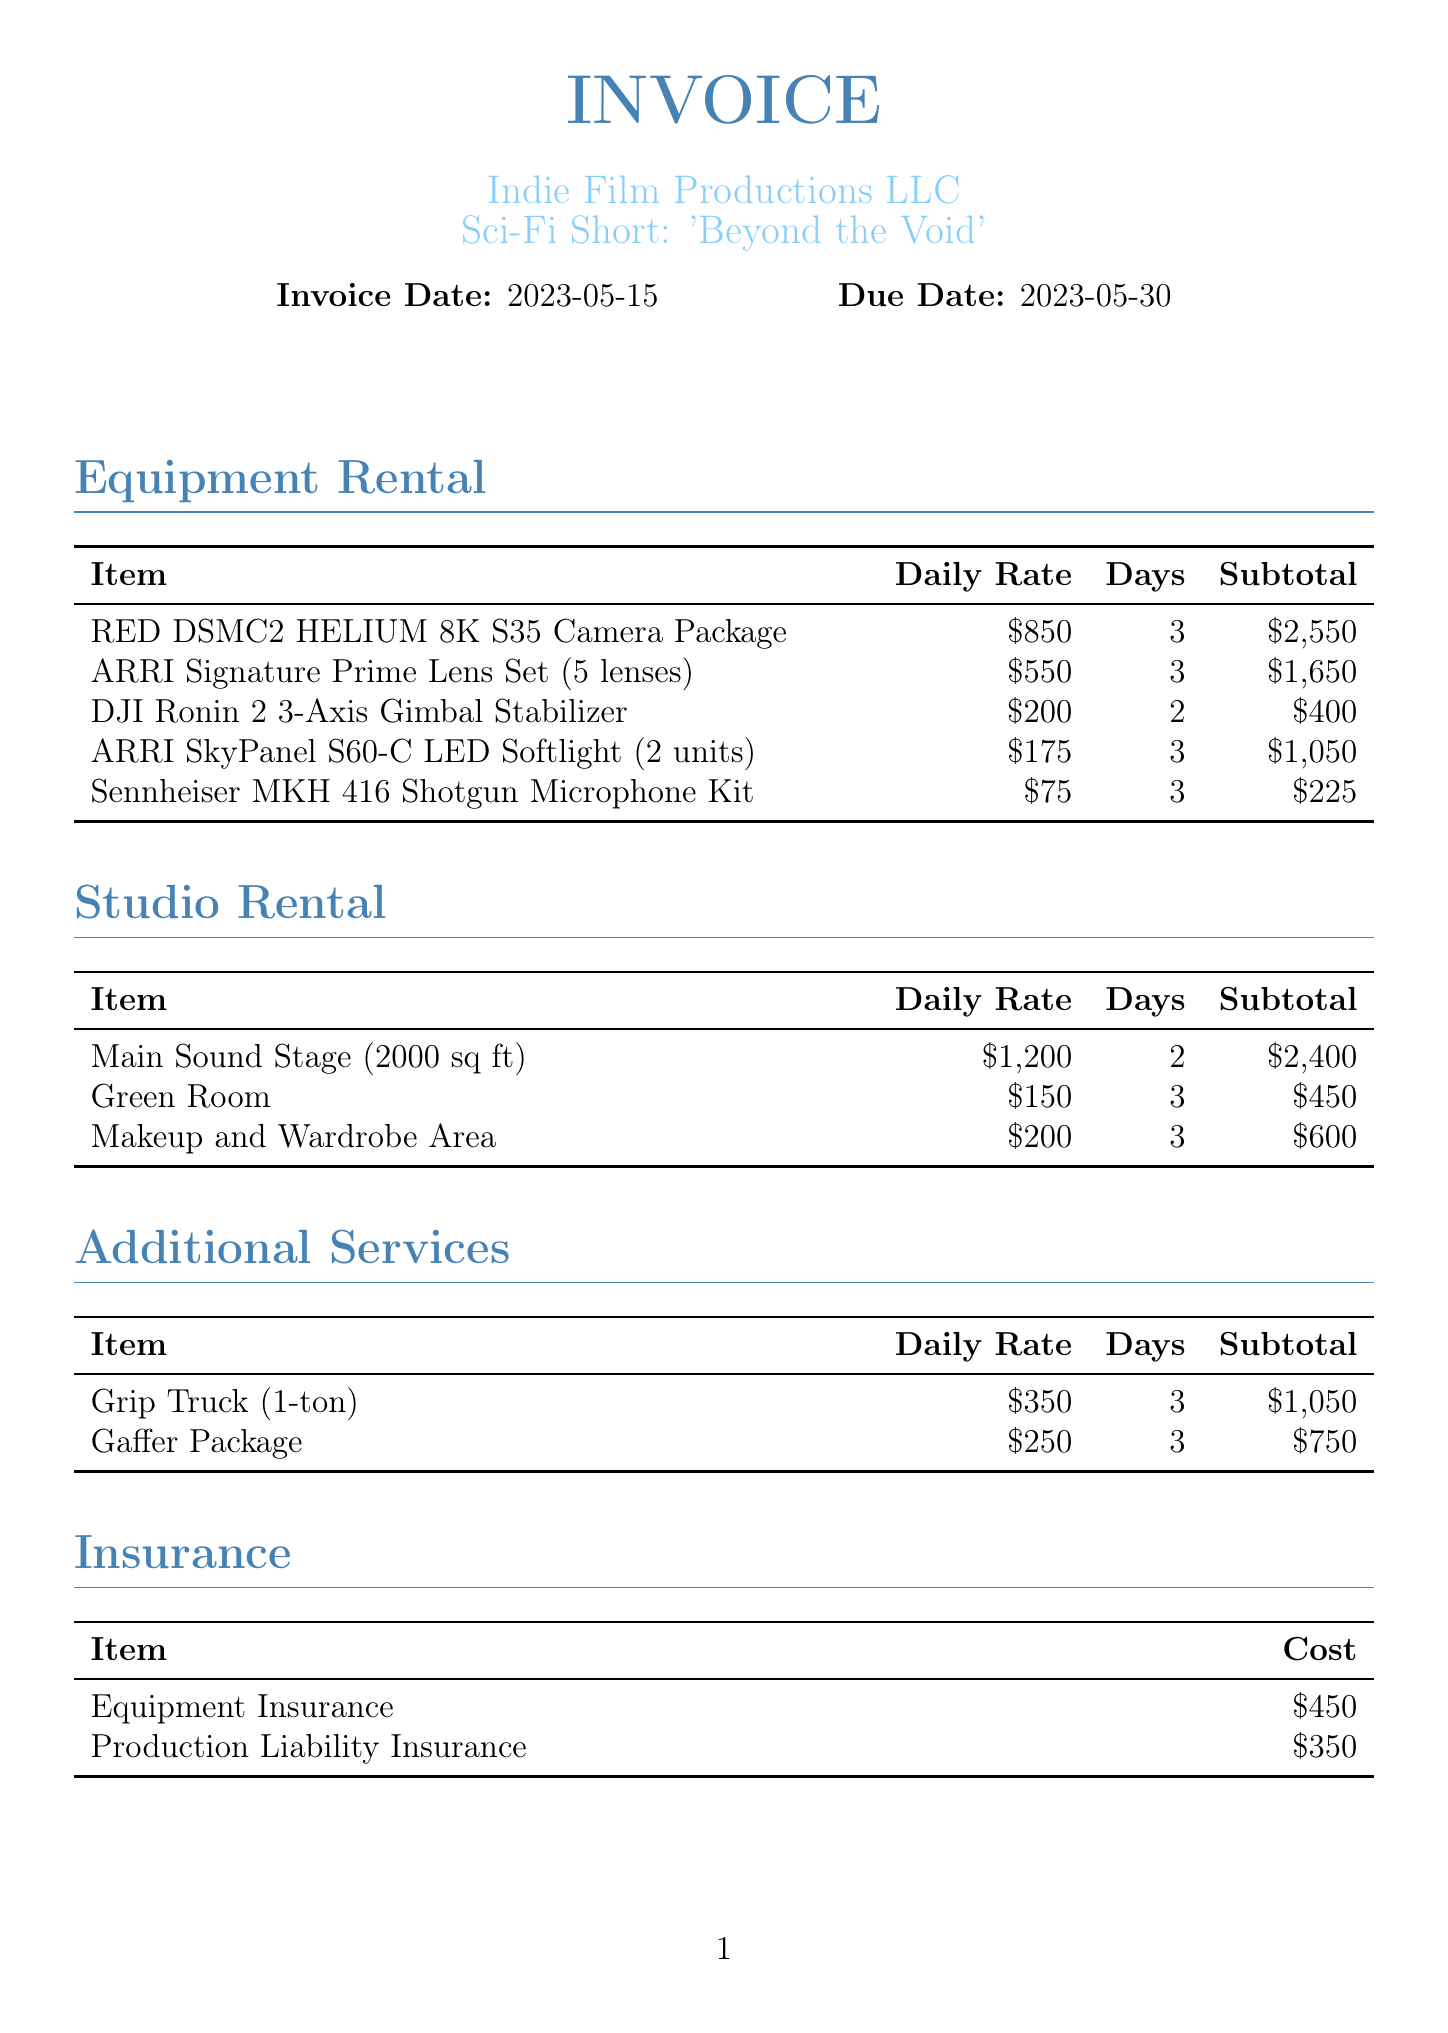What is the client's name? The client's name is listed in the invoice details section.
Answer: Indie Film Productions LLC What is the daily rate for the RED DSMC2 HELIUM 8K S35 Camera Package? The daily rate can be found in the equipment rental section under that specific item.
Answer: $850 How many days was the Main Sound Stage rented? The number of days for rental is specified in the studio rental section next to that item.
Answer: 2 What is the total cost for Production Liability Insurance? The total cost for insurance is indicated in the insurance section.
Answer: $350 What is the subtotal for catering services? The subtotal for catering services is detailed in the miscellaneous section for that specific item.
Answer: $675 What is the total invoice amount? The total invoice amount is listed at the bottom of the document.
Answer: $18,675 How many hours were billed for video editing? The hours billed are stated in the post-production section next to the video editing service.
Answer: 10 hours What is the total subtotal for crew services? The total can be deduced by adding the subtotals of each crew member listed in the crew section.
Answer: $5,250 How many days was the Sennheiser MKH 416 Shotgun Microphone Kit rented for? The number of rental days is specified in the equipment rental section next to that item.
Answer: 3 